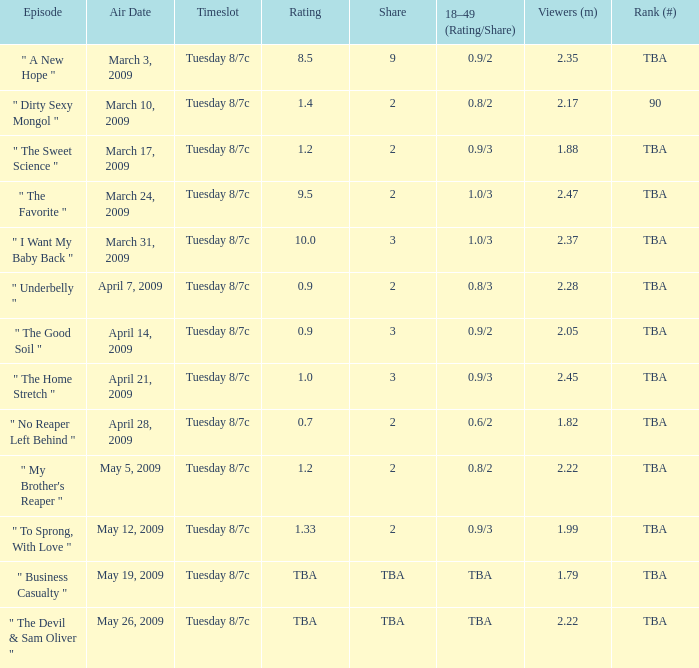What is the share of the 18-49 (Rating/Share) of 0.8/3? 2.0. 